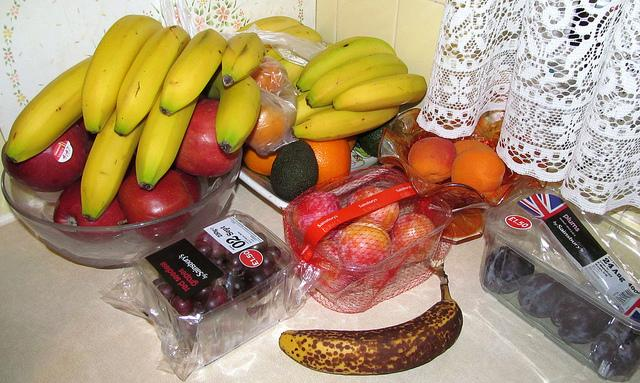What color is the banana without a bunch on the countertop directly? brown 